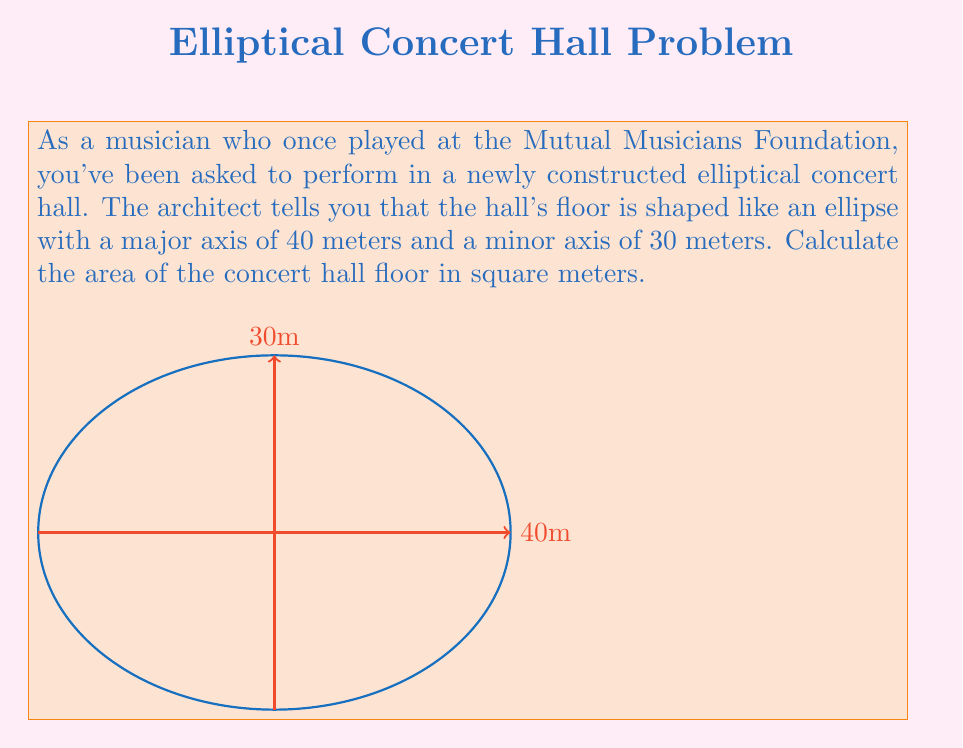Show me your answer to this math problem. To calculate the area of an elliptical floor, we need to use the formula for the area of an ellipse:

$$A = \pi ab$$

Where:
$A$ is the area
$a$ is half the length of the major axis
$b$ is half the length of the minor axis

Given:
- Major axis = 40 meters
- Minor axis = 30 meters

Step 1: Determine the values of $a$ and $b$
$a = 40 \div 2 = 20$ meters
$b = 30 \div 2 = 15$ meters

Step 2: Substitute these values into the formula
$$A = \pi \cdot 20 \cdot 15$$

Step 3: Calculate the result
$$A = \pi \cdot 300 = 300\pi \approx 942.48$$ square meters

Therefore, the area of the elliptical concert hall floor is $300\pi$ or approximately 942.48 square meters.
Answer: $300\pi$ m² 